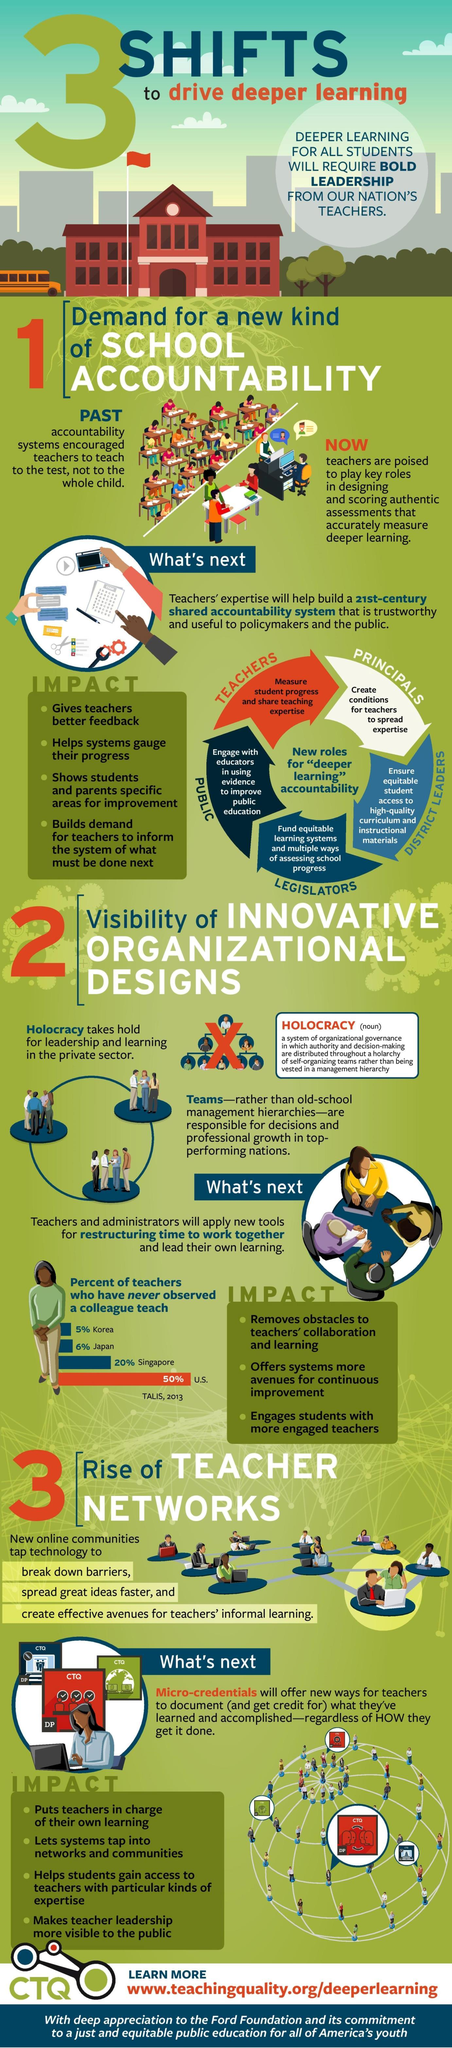Draw attention to some important aspects in this diagram. According to the TALIS report from 2013, 50% of teachers in the United States have never observed a colleague teach. District leaders are responsible for ensuring equitable student access to high-quality curriculum and instructional materials. It is the responsibility of legislators to fund equitable learning systems and multiple ways of assessing school progress. The responsibility for creating conditions that enable teachers to disseminate their expertise falls on the principals. Teachers are responsible for measuring student progress and sharing their teaching expertise. 